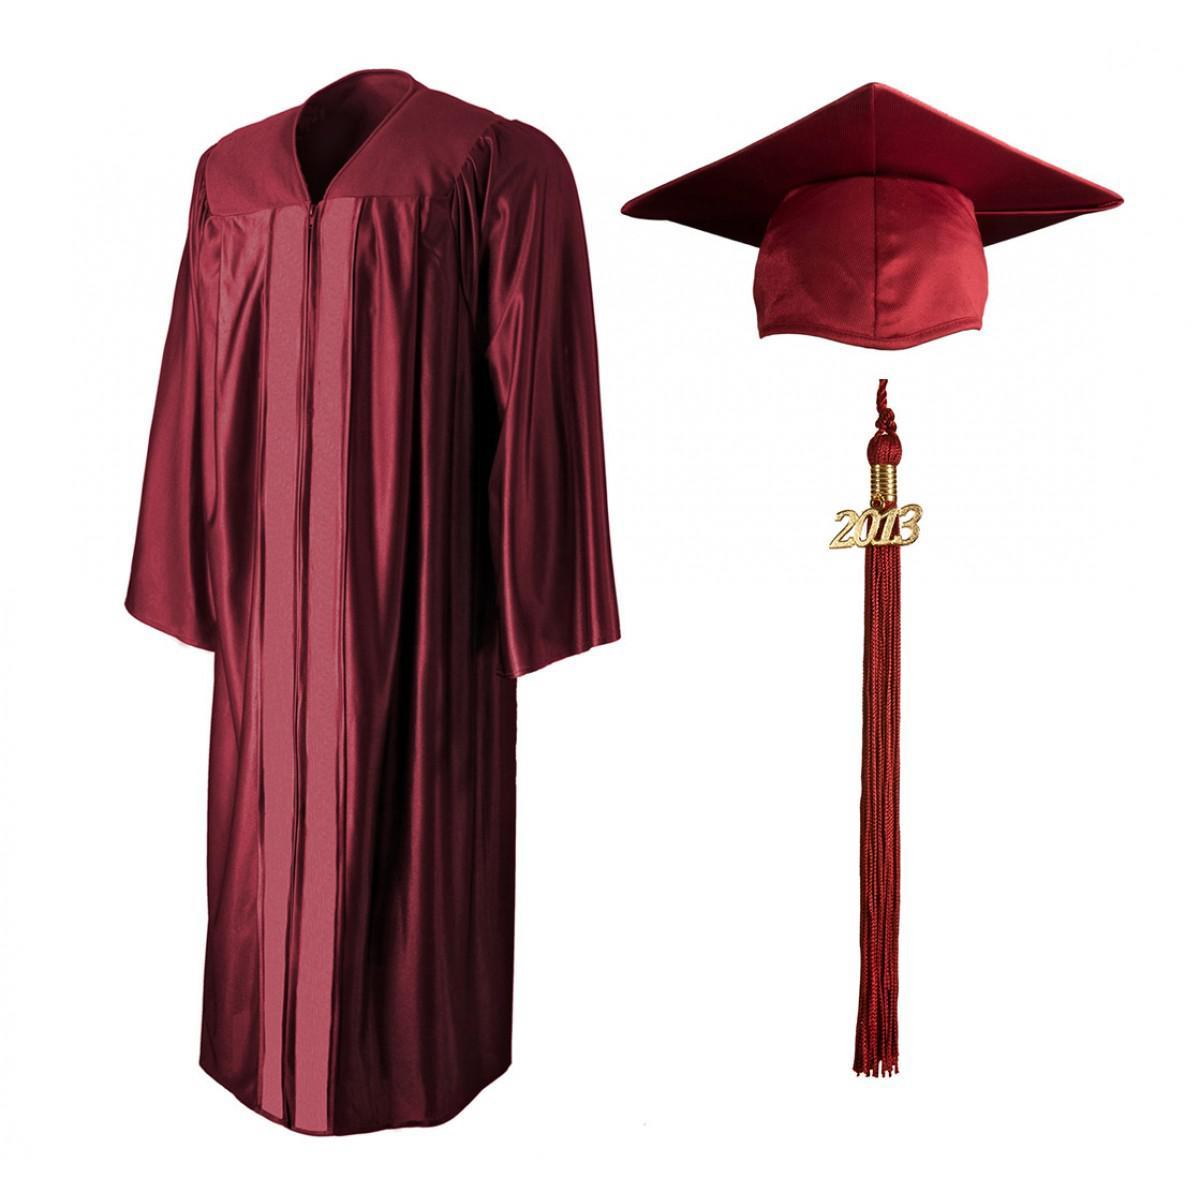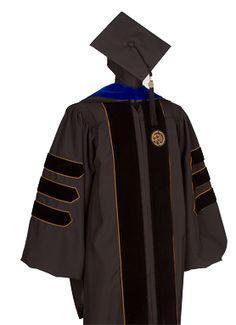The first image is the image on the left, the second image is the image on the right. Analyze the images presented: Is the assertion "An image shows a black graduation robe with bright blue around the collar, and the other image shows an unworn solid-colored gown." valid? Answer yes or no. Yes. 